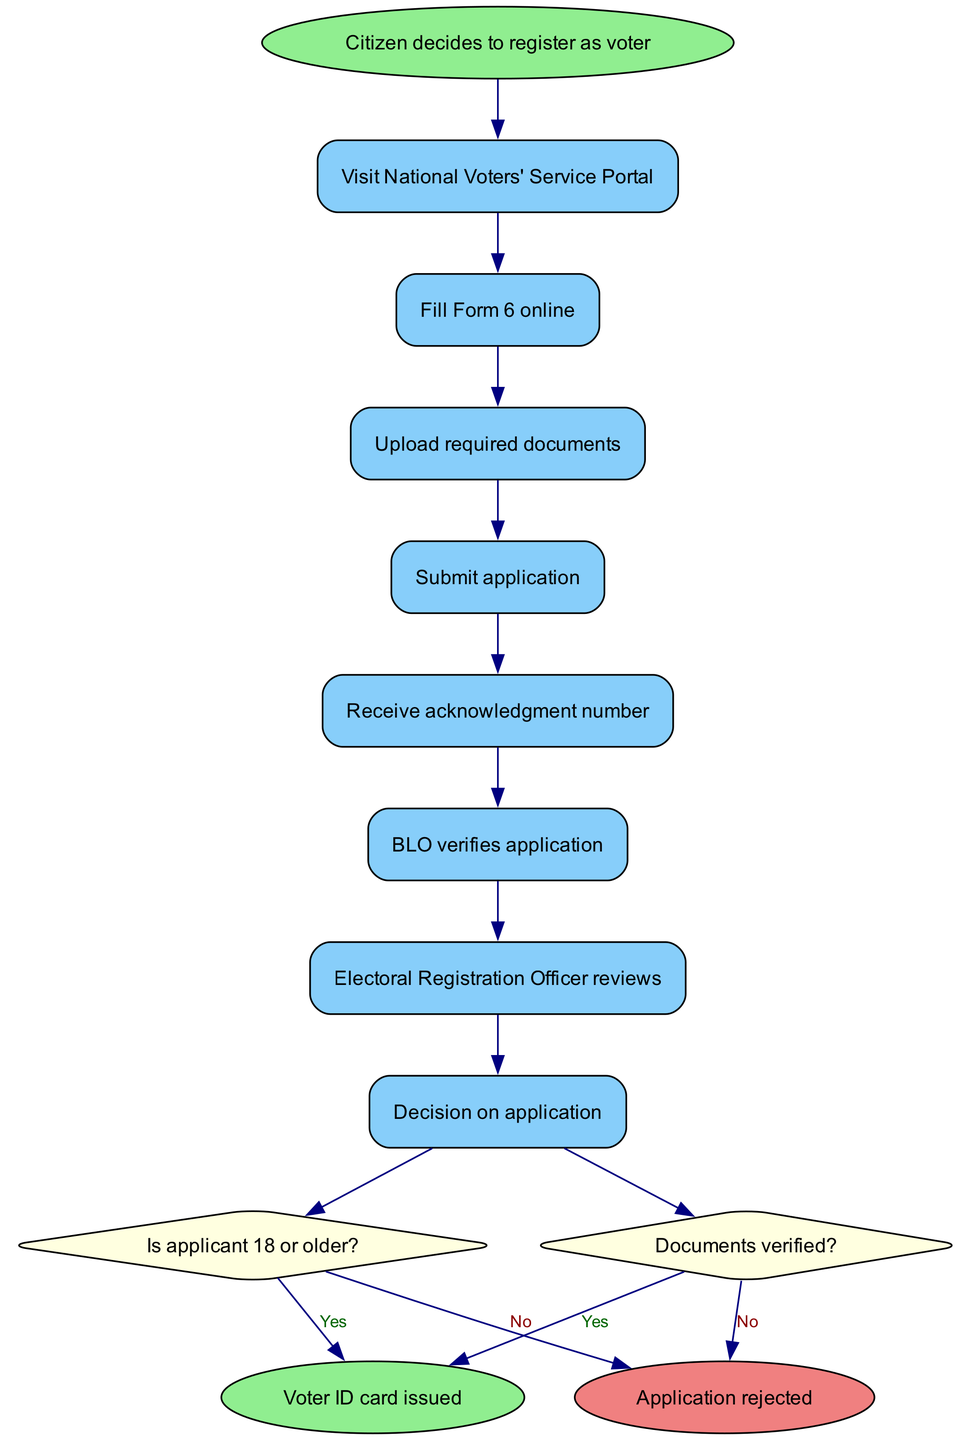What is the first activity in the process? The diagram starts with the node labeled "Citizen decides to register as voter", and the first activity is "Visit National Voters' Service Portal". This is the first step after the start node.
Answer: Visit National Voters' Service Portal How many decisions are there in the process? The diagram has two decision nodes: one that checks if the applicant is 18 or older, and another that verifies if the documents are valid. Thus, there are two decisions in total.
Answer: 2 What happens if the applicant is under 18? According to the diagram, if the answer to the decision "Is applicant 18 or older?" is "No", the flow leads to "Registration rejected". This indicates that the application cannot proceed.
Answer: Registration rejected What document is required to proceed after filling Form 6? After filling Form 6 online, the applicant is required to "Upload required documents" as the next step before submitting the application. Therefore, required documents are necessary at this stage.
Answer: Upload required documents What is the final outcome if the application is approved? The end node labeled "Voter ID card issued" signifies that if the application is approved, the final state of the process results in the issuance of a Voter ID card.
Answer: Voter ID card issued What condition is checked after the application is verified? The second decision checks the condition "Documents verified?". This occurs after the BLO verifies the application and before a final decision is made.
Answer: Documents verified? Where does the flow go if documents are not verified? If the documents are not verified (answer is "No"), the flow proceeds to the end state labeled "Application rejected", terminating the registration process at this point.
Answer: Application rejected What is required before submitting the application? Prior to submitting the application, the step "Upload required documents" must be completed. This is a necessary action that comes immediately before the submission.
Answer: Upload required documents How many activities are listed in the process? The diagram includes a total of eight activities that the applicant must complete, from visiting the portal to application submission and verification stages.
Answer: 8 